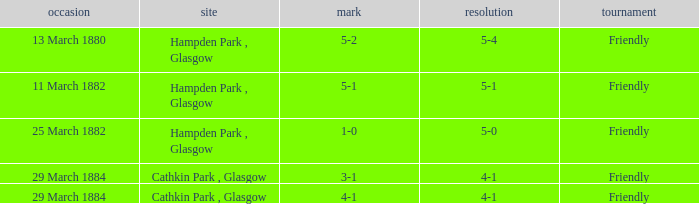Which item resulted in a score of 4-1? 3-1, 4-1. 